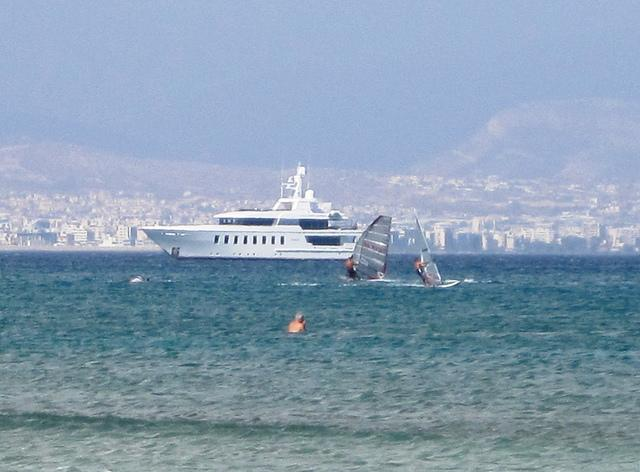How many people are holding onto parasail and sailing into the ocean? Please explain your reasoning. two. They each have one 